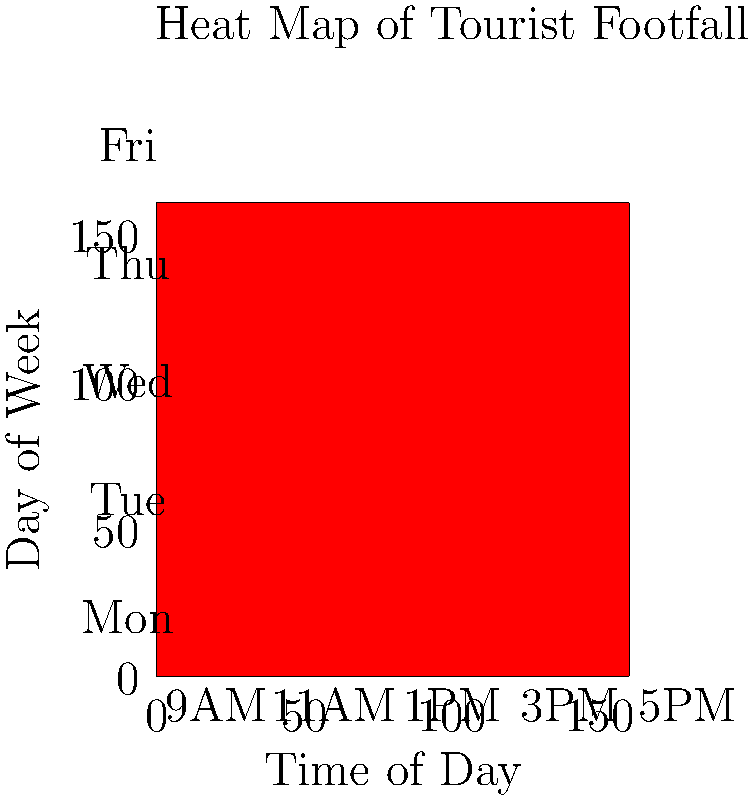As a travel journalist with a keen eye for detail, you're analyzing a heat map of tourist footfall at a popular landmark. The map shows data for 5 days (Monday to Friday) and 5 time slots (9AM to 5PM). If the average footfall across all time slots on Wednesday is 26, what is the estimated footfall at 3PM on Wednesday? Let's approach this step-by-step:

1) First, we need to identify the row corresponding to Wednesday. It's the middle row in the heat map.

2) The values for Wednesday are represented by colors. From left to right, we can estimate:
   9AM: Light blue (around 15)
   11AM: Green (around 20)
   1PM: Yellow (around 25)
   3PM: Orange (around 30)
   5PM: Red (around 40)

3) We're told that the average footfall across all time slots on Wednesday is 26. We can verify this:
   $\frac{15 + 20 + 25 + 30 + 40}{5} = \frac{130}{5} = 26$

4) This confirms that our color interpretation is correct.

5) The question asks for the estimated footfall at 3PM on Wednesday. From our color interpretation, this corresponds to the orange square, which we estimated to be around 30.

Therefore, the estimated footfall at 3PM on Wednesday is 30.
Answer: 30 